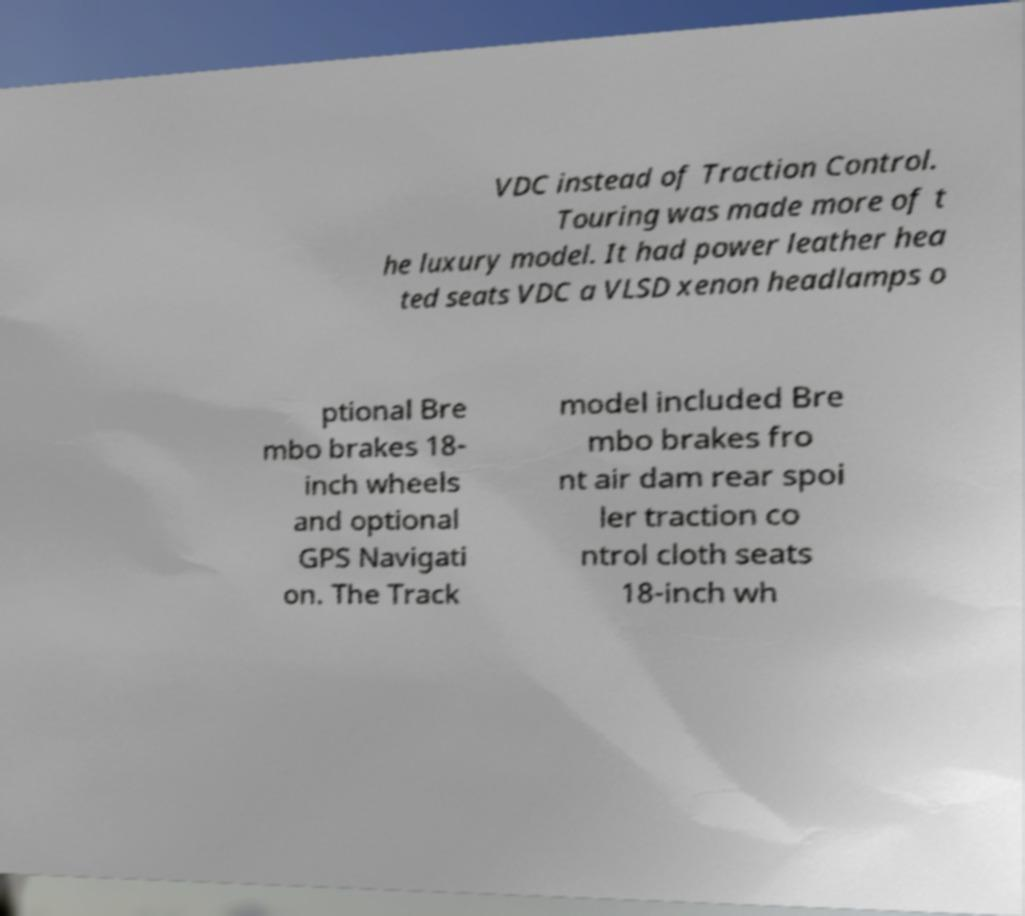Please identify and transcribe the text found in this image. VDC instead of Traction Control. Touring was made more of t he luxury model. It had power leather hea ted seats VDC a VLSD xenon headlamps o ptional Bre mbo brakes 18- inch wheels and optional GPS Navigati on. The Track model included Bre mbo brakes fro nt air dam rear spoi ler traction co ntrol cloth seats 18-inch wh 